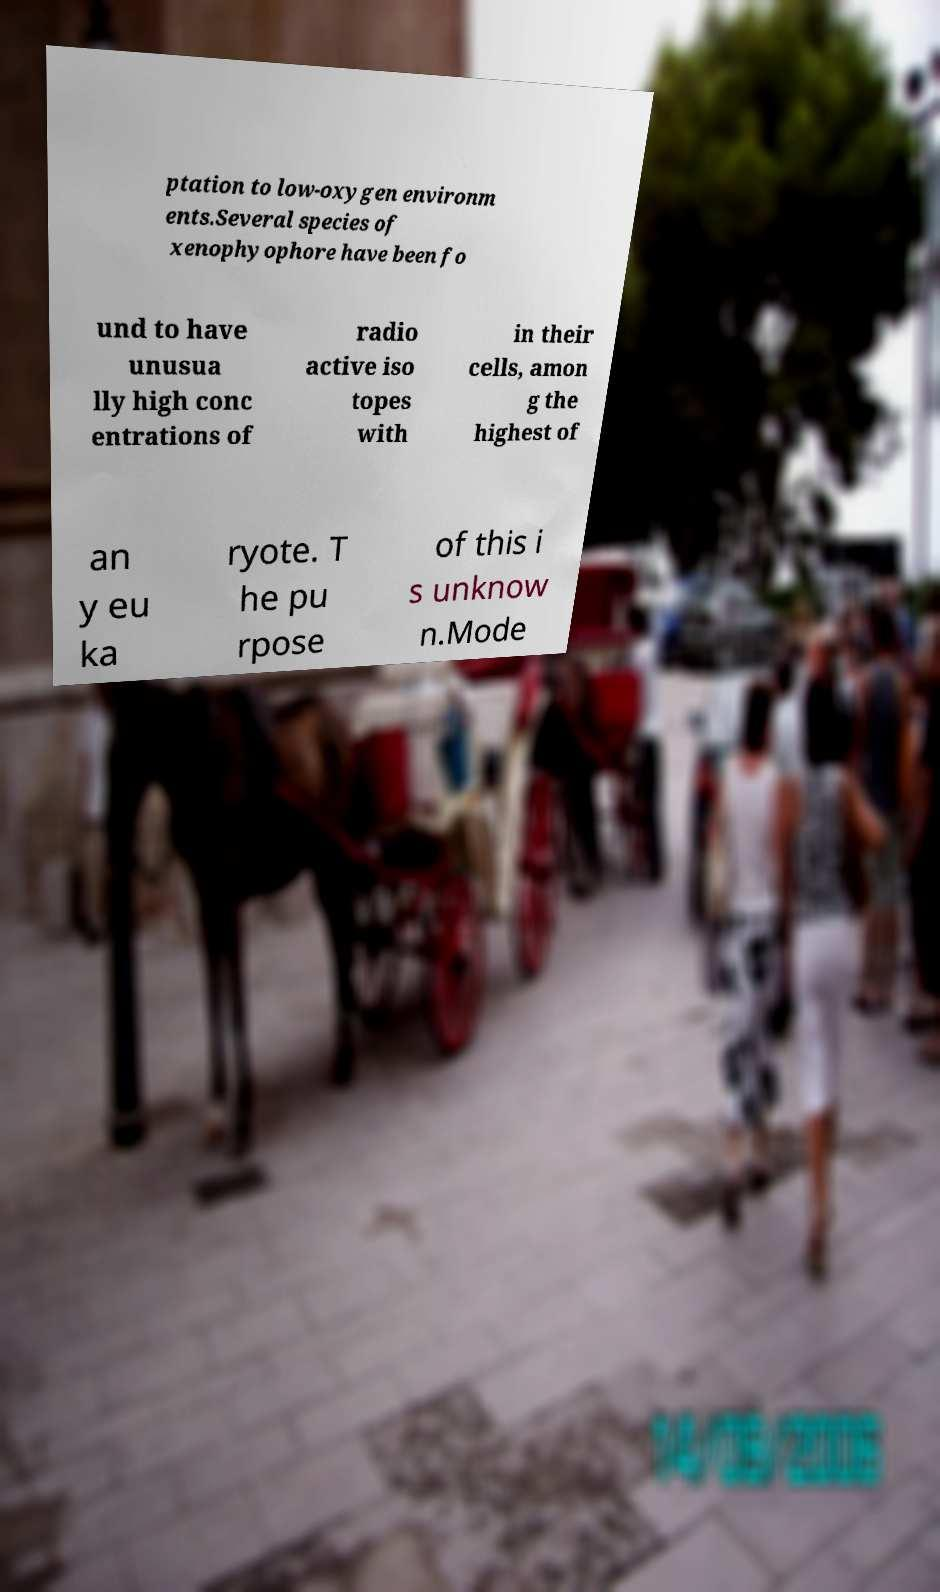Can you accurately transcribe the text from the provided image for me? ptation to low-oxygen environm ents.Several species of xenophyophore have been fo und to have unusua lly high conc entrations of radio active iso topes with in their cells, amon g the highest of an y eu ka ryote. T he pu rpose of this i s unknow n.Mode 